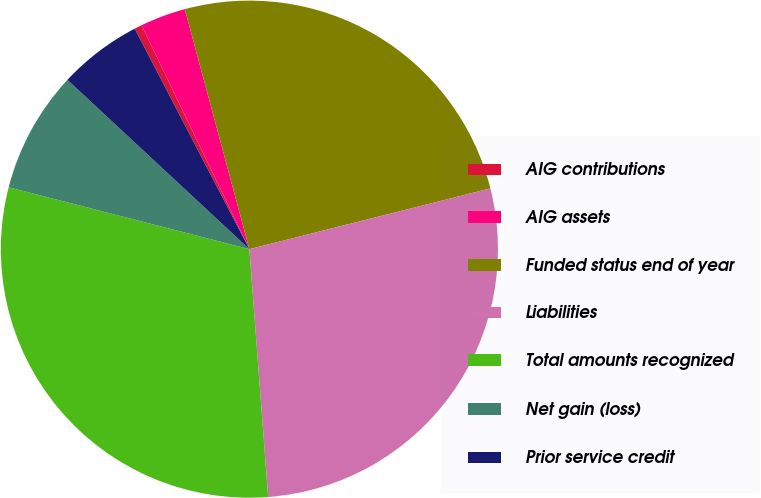<chart> <loc_0><loc_0><loc_500><loc_500><pie_chart><fcel>AIG contributions<fcel>AIG assets<fcel>Funded status end of year<fcel>Liabilities<fcel>Total amounts recognized<fcel>Net gain (loss)<fcel>Prior service credit<nl><fcel>0.49%<fcel>2.96%<fcel>25.25%<fcel>27.73%<fcel>30.21%<fcel>7.92%<fcel>5.44%<nl></chart> 